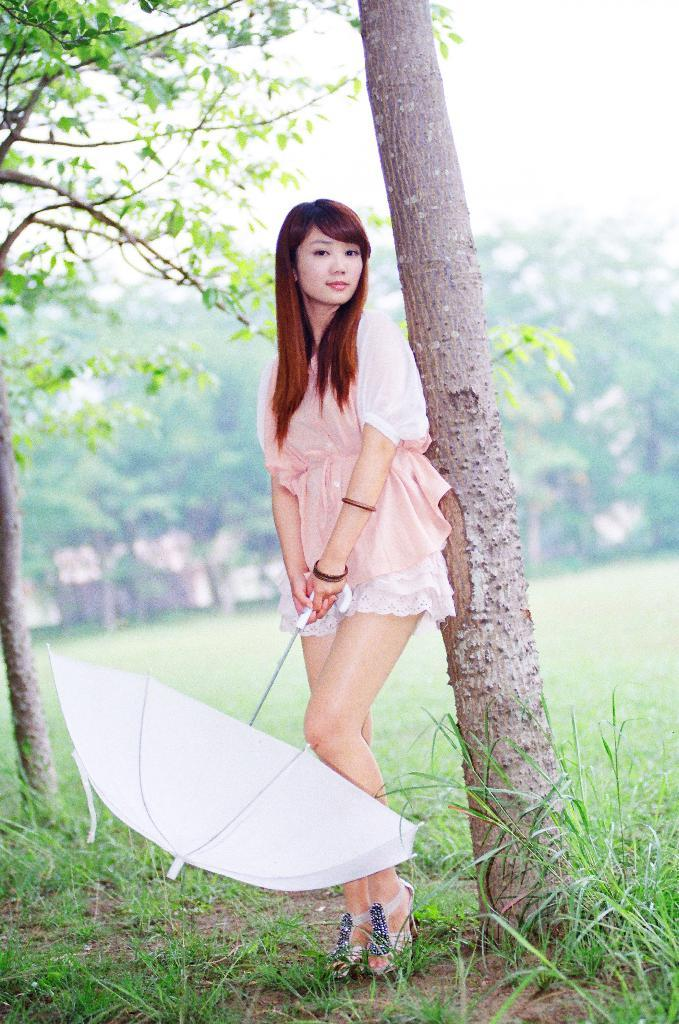What is the main subject of the image? There is a person standing in the image. What is the person holding in the image? The person is holding an object. What type of natural environment is visible in the image? There are many trees and a grassy land in the image. How would you describe the background of the image? The background of the image is blurred. What type of vegetable is being served on the plate in the image? There is no plate or vegetable present in the image. How does the wind affect the person's hair in the image? There is no indication of wind or its effect on the person's hair in the image. 